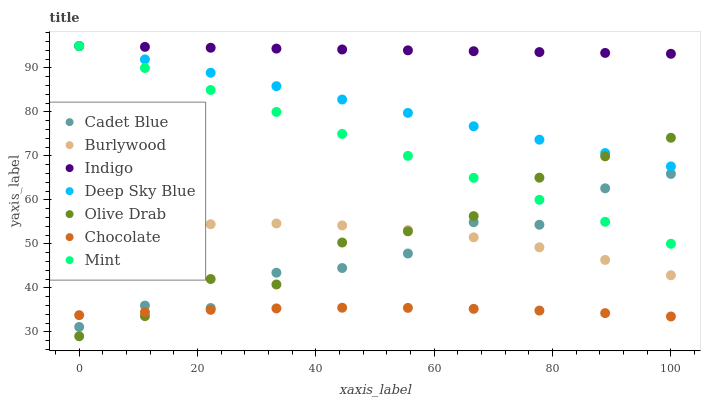Does Chocolate have the minimum area under the curve?
Answer yes or no. Yes. Does Indigo have the maximum area under the curve?
Answer yes or no. Yes. Does Burlywood have the minimum area under the curve?
Answer yes or no. No. Does Burlywood have the maximum area under the curve?
Answer yes or no. No. Is Deep Sky Blue the smoothest?
Answer yes or no. Yes. Is Cadet Blue the roughest?
Answer yes or no. Yes. Is Indigo the smoothest?
Answer yes or no. No. Is Indigo the roughest?
Answer yes or no. No. Does Olive Drab have the lowest value?
Answer yes or no. Yes. Does Burlywood have the lowest value?
Answer yes or no. No. Does Mint have the highest value?
Answer yes or no. Yes. Does Burlywood have the highest value?
Answer yes or no. No. Is Chocolate less than Mint?
Answer yes or no. Yes. Is Mint greater than Burlywood?
Answer yes or no. Yes. Does Burlywood intersect Cadet Blue?
Answer yes or no. Yes. Is Burlywood less than Cadet Blue?
Answer yes or no. No. Is Burlywood greater than Cadet Blue?
Answer yes or no. No. Does Chocolate intersect Mint?
Answer yes or no. No. 